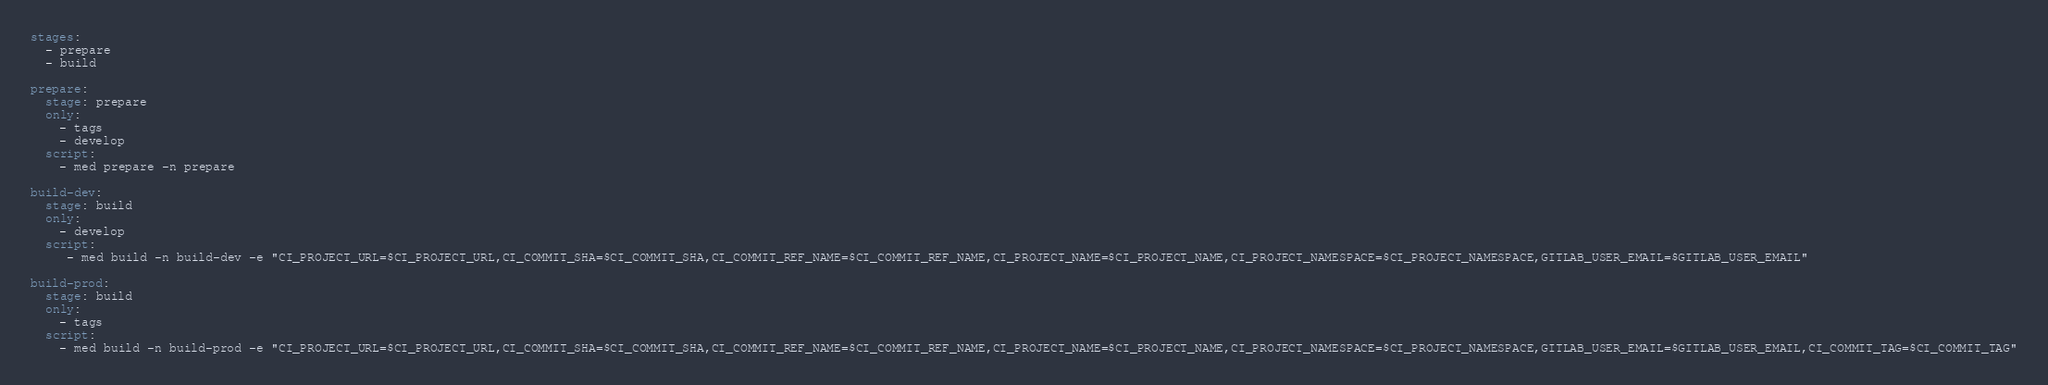<code> <loc_0><loc_0><loc_500><loc_500><_YAML_>stages:
  - prepare
  - build

prepare:
  stage: prepare
  only:
    - tags
    - develop
  script:
    - med prepare -n prepare

build-dev:
  stage: build
  only:
    - develop
  script:
     - med build -n build-dev -e "CI_PROJECT_URL=$CI_PROJECT_URL,CI_COMMIT_SHA=$CI_COMMIT_SHA,CI_COMMIT_REF_NAME=$CI_COMMIT_REF_NAME,CI_PROJECT_NAME=$CI_PROJECT_NAME,CI_PROJECT_NAMESPACE=$CI_PROJECT_NAMESPACE,GITLAB_USER_EMAIL=$GITLAB_USER_EMAIL"

build-prod:
  stage: build
  only:
    - tags
  script:
    - med build -n build-prod -e "CI_PROJECT_URL=$CI_PROJECT_URL,CI_COMMIT_SHA=$CI_COMMIT_SHA,CI_COMMIT_REF_NAME=$CI_COMMIT_REF_NAME,CI_PROJECT_NAME=$CI_PROJECT_NAME,CI_PROJECT_NAMESPACE=$CI_PROJECT_NAMESPACE,GITLAB_USER_EMAIL=$GITLAB_USER_EMAIL,CI_COMMIT_TAG=$CI_COMMIT_TAG"
</code> 